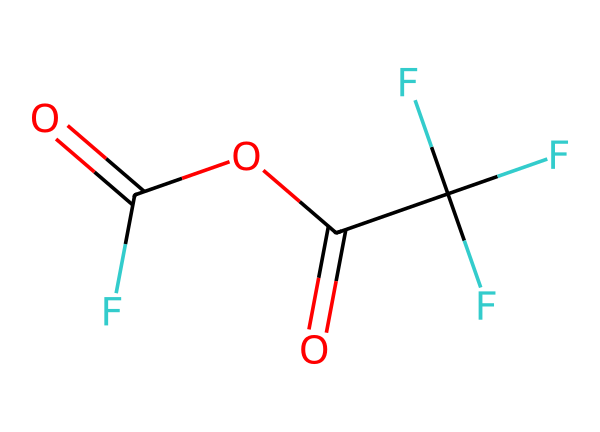What is the molecular formula of this compound? To determine the molecular formula, we can count the number of each type of atom in the SMILES representation. The structure indicates there are 2 carbon (C) atoms, 4 fluorine (F) atoms, 2 oxygen (O) atoms, and 2 hydrogen (H) atoms. Thus, the molecular formula is C2H2F4O2.
Answer: C2H2F4O2 How many carbon atoms does this molecule contain? The SMILES notation shows two carbon (C) atoms connected in the structure, confirming that there are two carbon atoms present.
Answer: 2 What functional groups are present in this structure? The presence of the carbonyl groups (C=O) and the ether link (C-O-C) indicates that the molecule contains an anhydride functional group, along with the features of trifluoroacetic acid.
Answer: anhydride, carbonyl How many oxygen atoms are present in this molecule? By analyzing the SMILES representation, we can see there are two oxygen (O) atoms in the structure, one from each carbonyl group connected by an ether link.
Answer: 2 What is the significance of the trifluoro substituents in terms of acidity? The trifluoro substituents increase the electron-withdrawing effect and stabilize the conjugate base formed during reactions, enhancing acidity due to the strong electronegativity of fluorine.
Answer: enhance acidity What type of reaction can trifluoroacetic anhydride undergo in pharmaceutical development? Trifluoroacetic anhydride can undergo acylation reactions in pharmaceutical development, where it can introduce the acyl group into various substrates, forming esters or amides.
Answer: acylation What is the expected physical state of trifluoroacetic anhydride at room temperature? This compound, like other anhydrides, generally presents itself as a liquid at room temperature due to its molecular structure and relatively low molecular weight.
Answer: liquid 